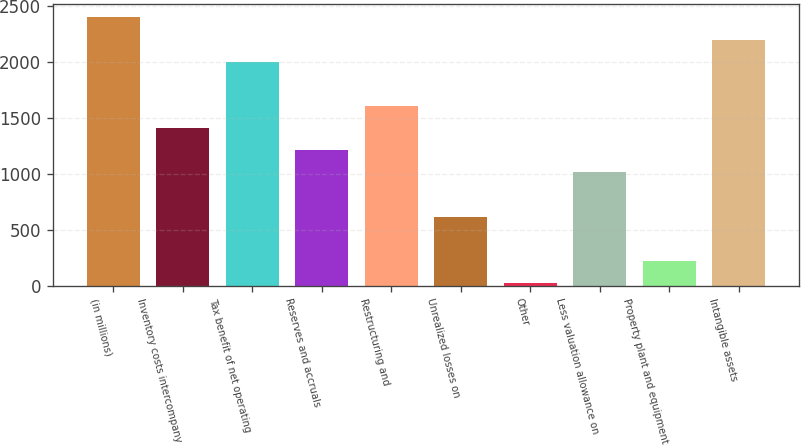Convert chart to OTSL. <chart><loc_0><loc_0><loc_500><loc_500><bar_chart><fcel>(in millions)<fcel>Inventory costs intercompany<fcel>Tax benefit of net operating<fcel>Reserves and accruals<fcel>Restructuring and<fcel>Unrealized losses on<fcel>Other<fcel>Less valuation allowance on<fcel>Property plant and equipment<fcel>Intangible assets<nl><fcel>2399.2<fcel>1408.7<fcel>2003<fcel>1210.6<fcel>1606.8<fcel>616.3<fcel>22<fcel>1012.5<fcel>220.1<fcel>2201.1<nl></chart> 